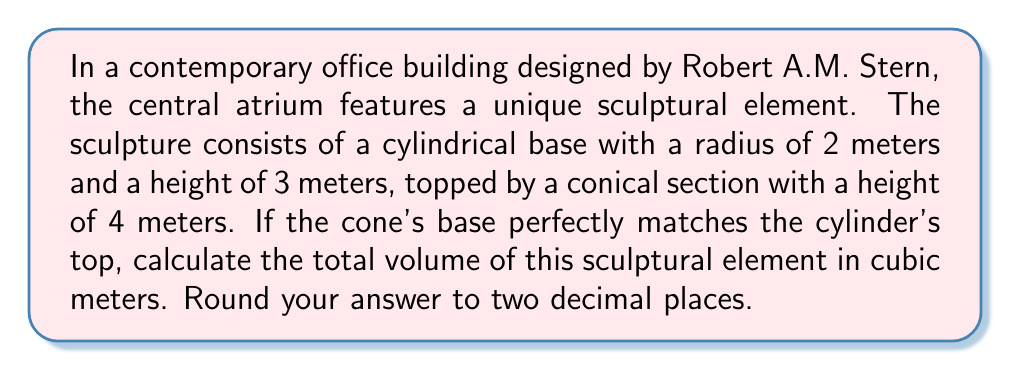Give your solution to this math problem. Let's approach this problem step-by-step:

1) First, we need to calculate the volume of the cylindrical base:
   The formula for the volume of a cylinder is $V_{cylinder} = \pi r^2 h$
   Where $r$ is the radius and $h$ is the height.
   
   $V_{cylinder} = \pi (2m)^2 (3m) = 12\pi$ cubic meters

2) Next, we calculate the volume of the conical top:
   The formula for the volume of a cone is $V_{cone} = \frac{1}{3}\pi r^2 h$
   Where $r$ is the radius of the base and $h$ is the height.
   
   $V_{cone} = \frac{1}{3}\pi (2m)^2 (4m) = \frac{16}{3}\pi$ cubic meters

3) The total volume is the sum of these two parts:
   $V_{total} = V_{cylinder} + V_{cone}$
   $V_{total} = 12\pi + \frac{16}{3}\pi = \frac{52}{3}\pi$ cubic meters

4) Converting to a decimal and rounding to two places:
   $\frac{52}{3}\pi \approx 54.54$ cubic meters

[asy]
import geometry;

size(200);

// Draw cylinder
path p = (2,0)--(2,3)--(-2,3)--(-2,0);
draw(p);
draw(ellipse((0,0),2,0.5),dashed);
draw(ellipse((0,3),2,0.5));

// Draw cone
draw((2,3)--(0,7)--(-2,3));

// Labels
label("3m", (2.5,1.5), E);
label("4m", (2.5,5), E);
label("2m", (1,-0.5), S);

</asy>
Answer: $54.54$ cubic meters 